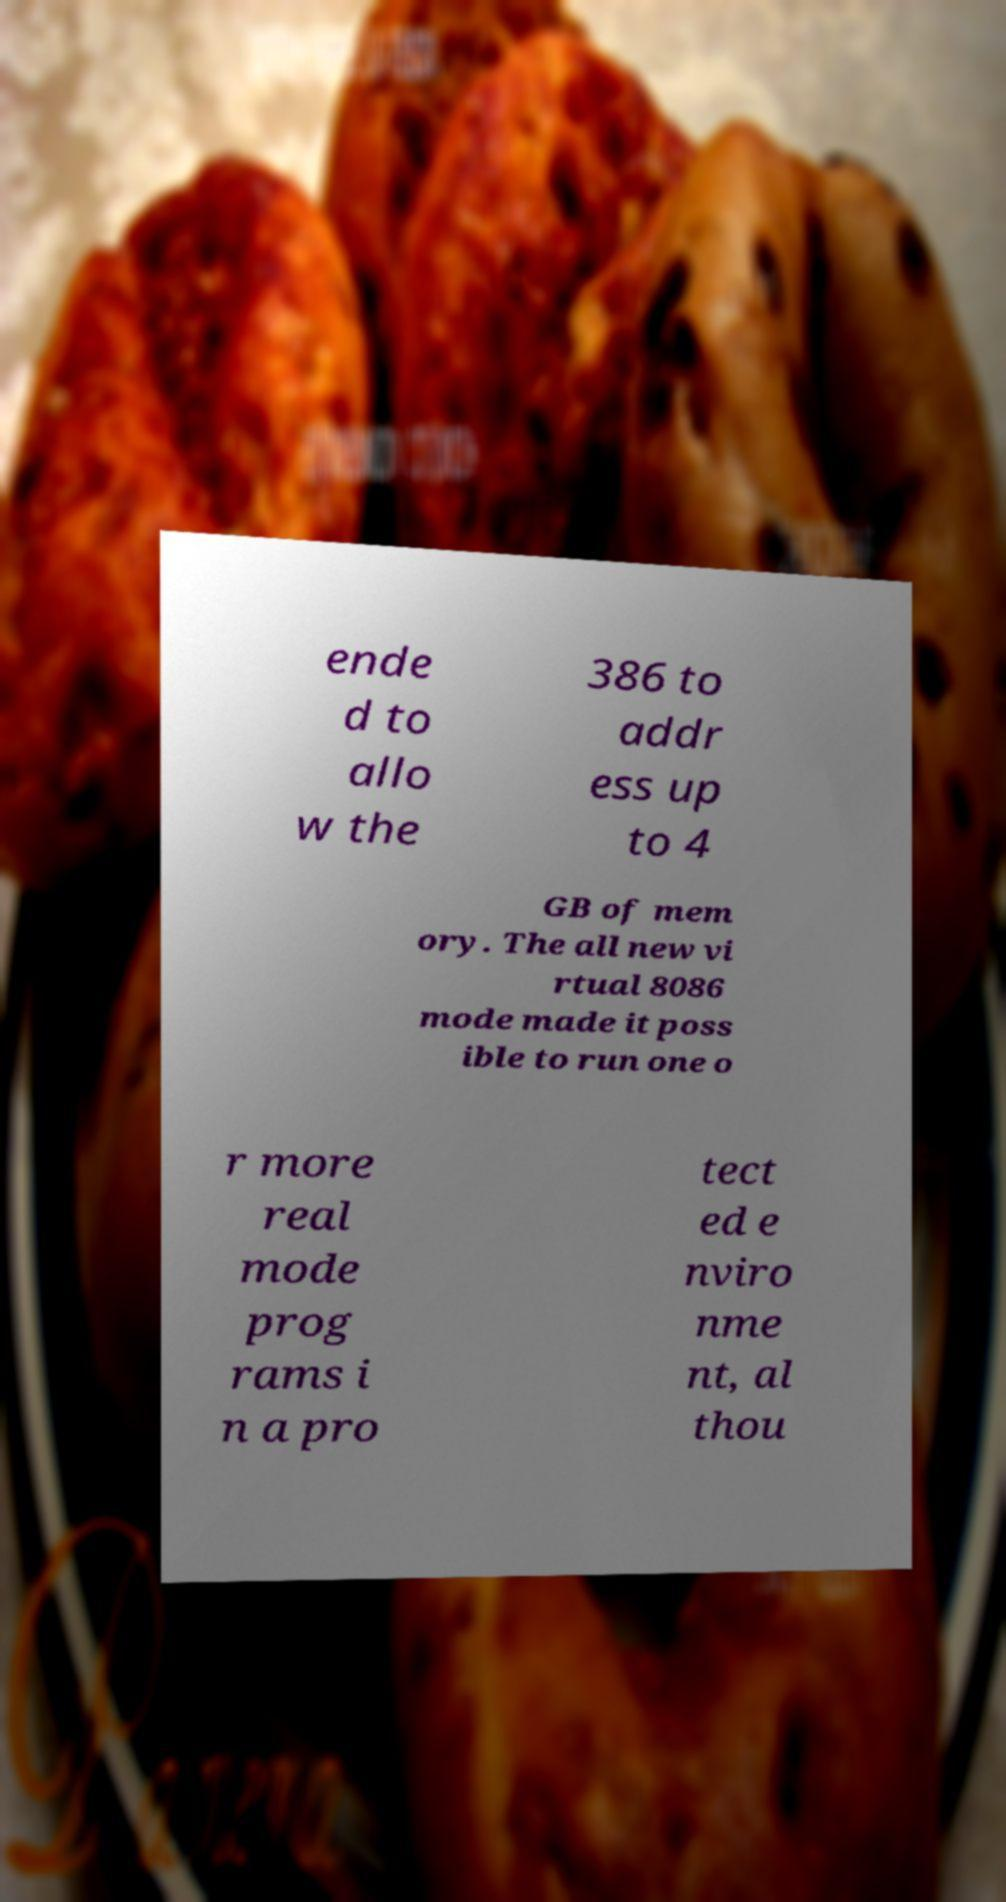Please read and relay the text visible in this image. What does it say? ende d to allo w the 386 to addr ess up to 4 GB of mem ory. The all new vi rtual 8086 mode made it poss ible to run one o r more real mode prog rams i n a pro tect ed e nviro nme nt, al thou 